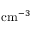Convert formula to latex. <formula><loc_0><loc_0><loc_500><loc_500>c m ^ { - 3 }</formula> 